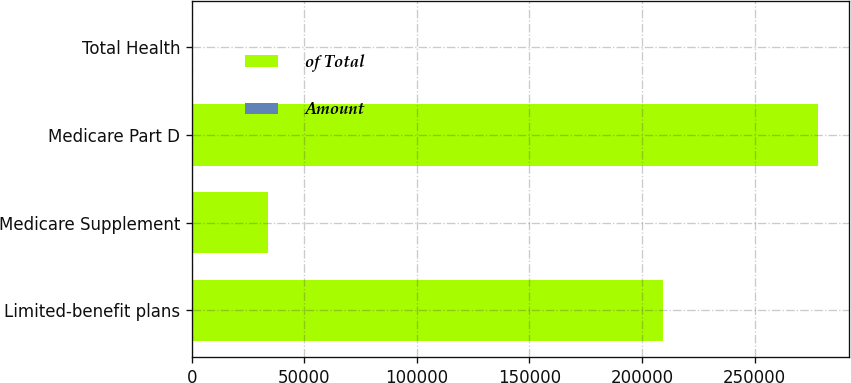<chart> <loc_0><loc_0><loc_500><loc_500><stacked_bar_chart><ecel><fcel>Limited-benefit plans<fcel>Medicare Supplement<fcel>Medicare Part D<fcel>Total Health<nl><fcel>of Total<fcel>209258<fcel>33980<fcel>278023<fcel>100<nl><fcel>Amount<fcel>40<fcel>7<fcel>53<fcel>100<nl></chart> 